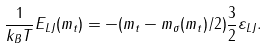Convert formula to latex. <formula><loc_0><loc_0><loc_500><loc_500>\frac { 1 } { k _ { B } T } E _ { L J } ( m _ { t } ) = - ( m _ { t } - m _ { \sigma } ( m _ { t } ) / 2 ) \frac { 3 } { 2 } \varepsilon _ { L J } .</formula> 